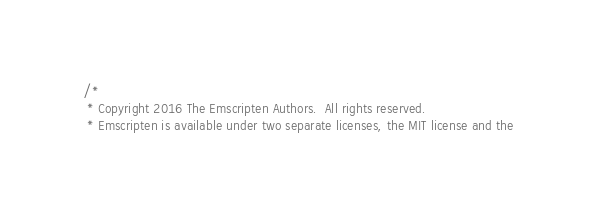<code> <loc_0><loc_0><loc_500><loc_500><_C_>/*
 * Copyright 2016 The Emscripten Authors.  All rights reserved.
 * Emscripten is available under two separate licenses, the MIT license and the</code> 